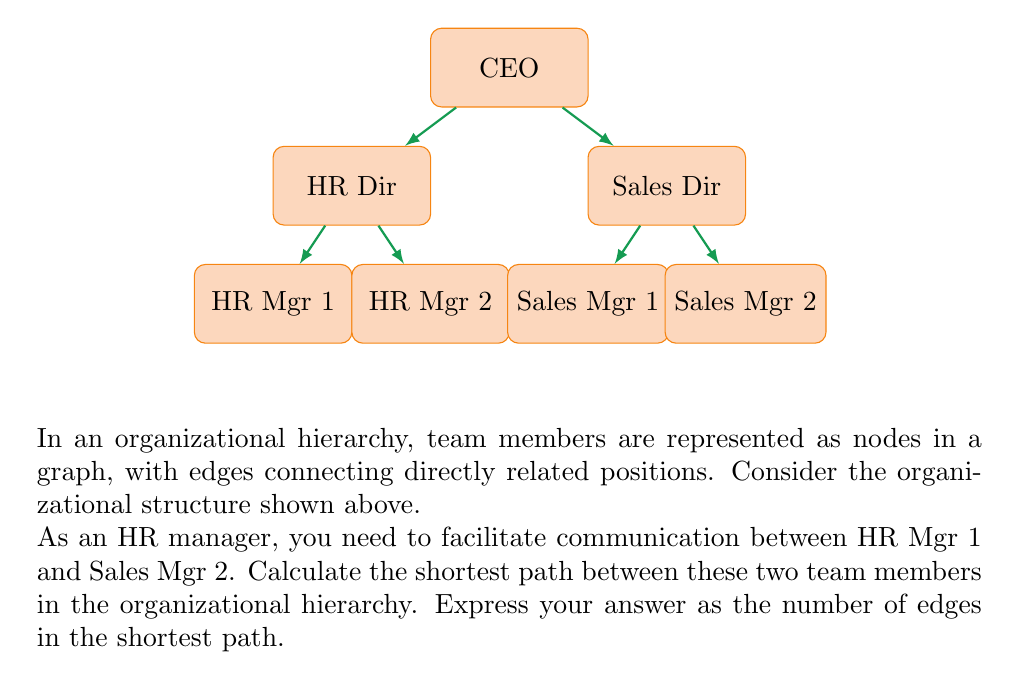Can you solve this math problem? To solve this problem, we need to find the shortest path between HR Mgr 1 and Sales Mgr 2 in the given organizational hierarchy. Let's approach this step-by-step:

1) First, let's identify the positions of HR Mgr 1 and Sales Mgr 2 in the hierarchy:
   - HR Mgr 1 is at the bottom left of the diagram
   - Sales Mgr 2 is at the bottom right of the diagram

2) Now, let's trace the path from HR Mgr 1 to the CEO:
   HR Mgr 1 -> HR Dir -> CEO
   This path has 2 edges.

3) Then, let's trace the path from the CEO to Sales Mgr 2:
   CEO -> Sales Dir -> Sales Mgr 2
   This path also has 2 edges.

4) The shortest path between HR Mgr 1 and Sales Mgr 2 will go through their lowest common ancestor in the hierarchy, which in this case is the CEO.

5) To calculate the total number of edges in the shortest path, we add the number of edges from HR Mgr 1 to the CEO and from the CEO to Sales Mgr 2:

   $$\text{Total edges} = \text{Edges (HR Mgr 1 to CEO)} + \text{Edges (CEO to Sales Mgr 2)}$$
   $$\text{Total edges} = 2 + 2 = 4$$

Therefore, the shortest path between HR Mgr 1 and Sales Mgr 2 consists of 4 edges.
Answer: 4 edges 